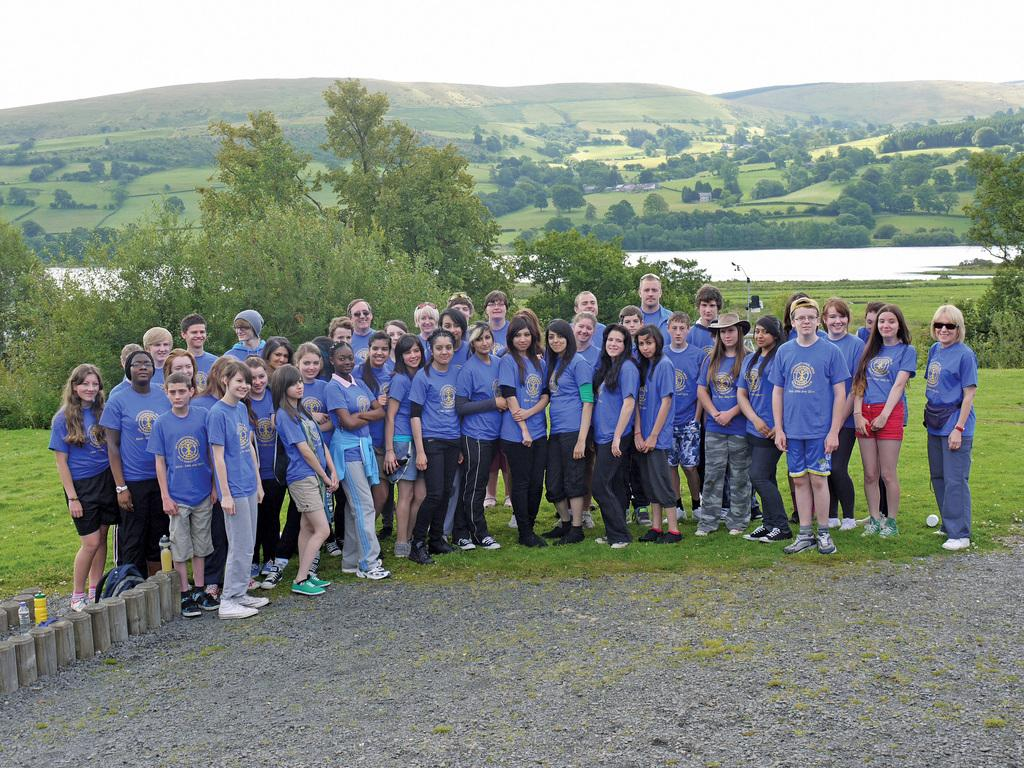What can be seen in the image? There is a group of people in the image. What are the people wearing? The people are wearing blue t-shirts. What is visible in the background of the image? There are trees and mountains in the backdrop of the image. What is the condition of the sky in the image? The sky is clear in the image. How many eggs are being held by the boy in the image? There is no boy present in the image, and therefore no eggs being held. Are there any slaves depicted in the image? There is no mention of slaves in the image, and no such figures are visible. 